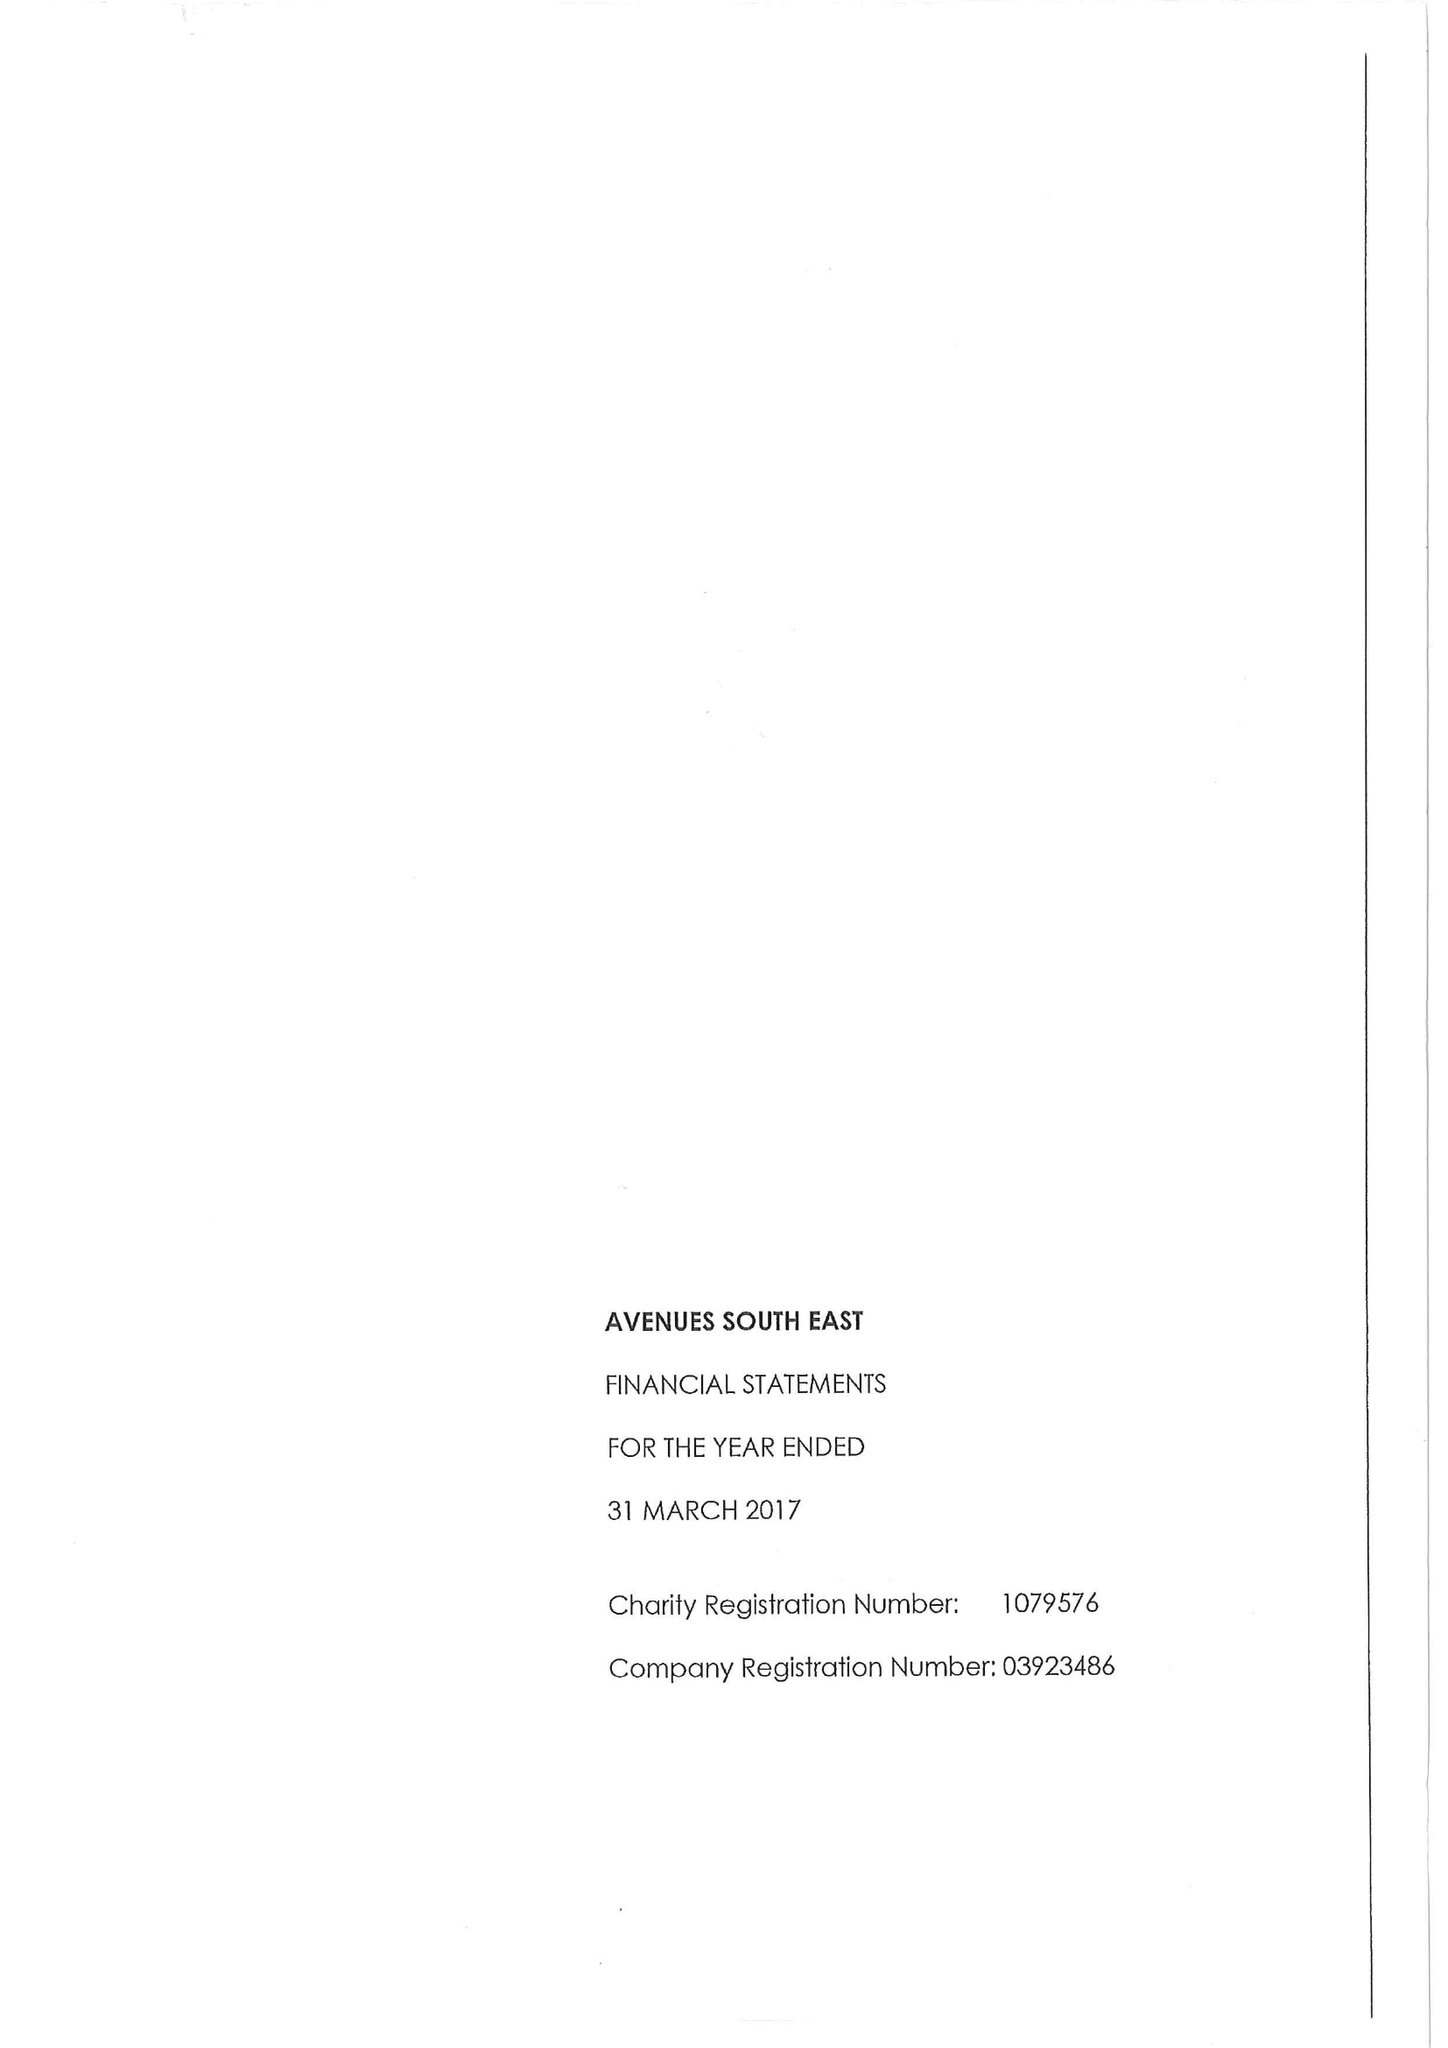What is the value for the charity_number?
Answer the question using a single word or phrase. 1079576 